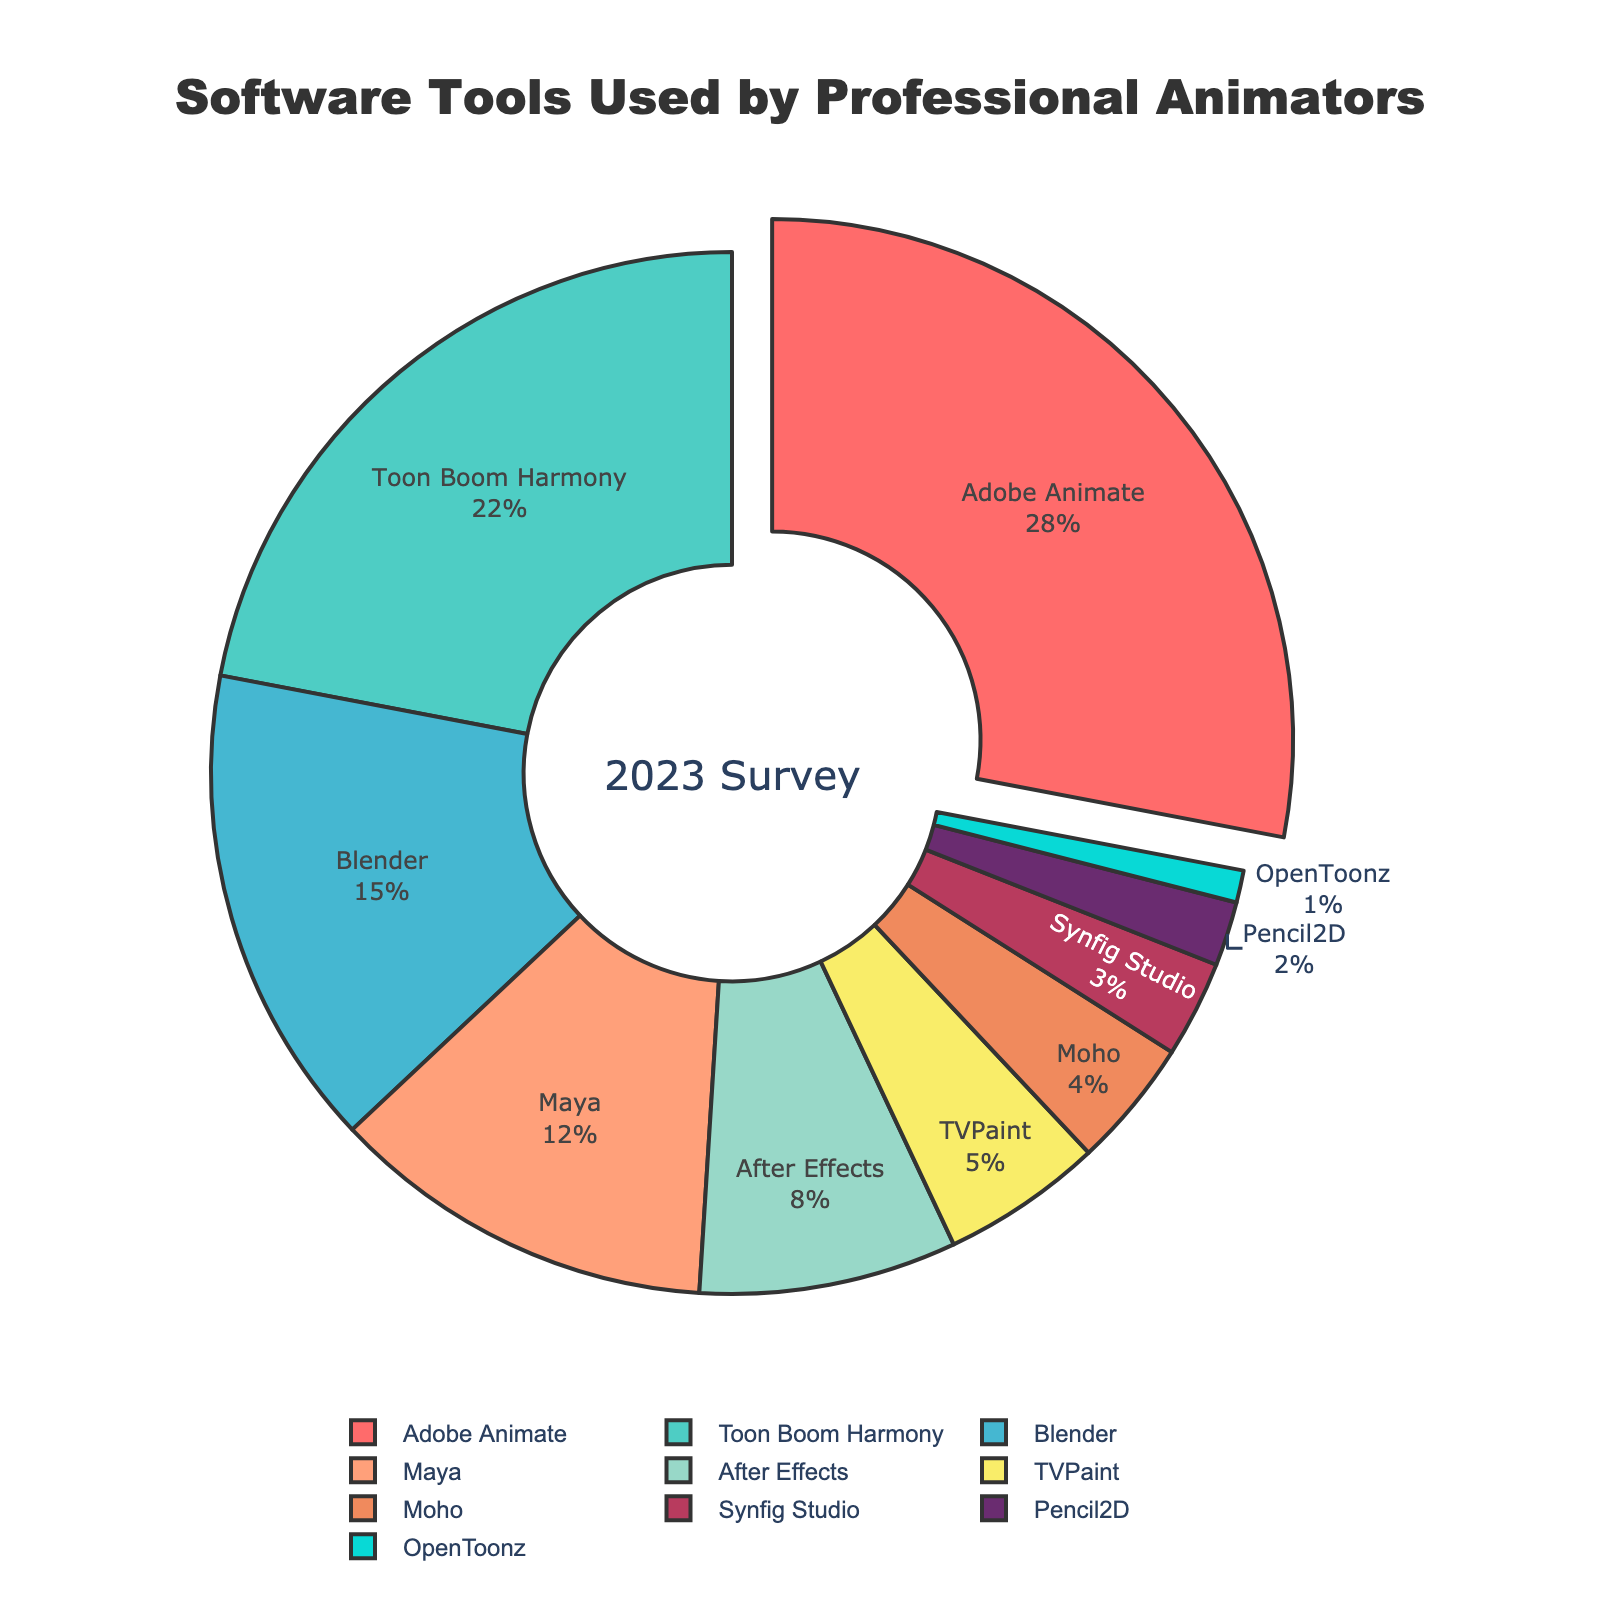Which software tool is used by the highest proportion of professional animators? The slice with the highest proportion is pulled out and is labeled "Adobe Animate" with 28%.
Answer: Adobe Animate Which two software tools have combined usage that almost equals Adobe Animate’s usage? Adobe Animate has 28%. Toon Boom Harmony and Blender have 22% and 15%, respectively, and combining these gives 37%, which exceeds Adobe Animate. The closest total is Toon Boom Harmony and After Effects, which together sum to 30%.
Answer: Toon Boom Harmony and After Effects Is the proportion of Blender higher than the proportion of Maya? Comparing the labelled percentages of Blender and Maya, Blender has 15% and Maya has 12%.
Answer: Yes What is the visual color used for After Effects? The color for After Effects is identified by the corresponding slice which is a pale yellow-green shade.
Answer: Pale yellow-green What is the percentage difference between Toon Boom Harmony and Moho? Toon Boom Harmony shows 22%, and Moho shows 4%. The difference is 22% - 4% = 18%.
Answer: 18% Could the proportion of TVPaint and Synfig Studio combined exceed Blender's proportion? TVPaint is 5% and Synfig Studio is 3%, giving a combined total of 8%, which is less than Blender's 15%.
Answer: No Which software tools combined represent less than 10% of the total usage? Adding the smallest slices: OpenToonz 1%, Pencil2D 2%, Synfig Studio 3%, and Moho 4% gives a total of 10%. Removing any one of these results in a total below 10%.
Answer: OpenToonz, Pencil2D, Synfig Studio, Moho What percent of animators use software that is neither Adobe Animate nor Toon Boom Harmony? Adobe Animate is 28% and Toon Boom Harmony is 22%. The rest sum up to 100% - (28% + 22%) = 50%.
Answer: 50% Which slice has the smallest proportion, and what color represents it? The smallest slice is labeled "OpenToonz" with 1%, represented by a bright blue.
Answer: OpenToonz, bright blue 